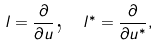Convert formula to latex. <formula><loc_0><loc_0><loc_500><loc_500>l = \frac { \partial } { \partial u } \text {, \ } l ^ { \ast } = \frac { \partial } { \partial u ^ { \ast } } ,</formula> 